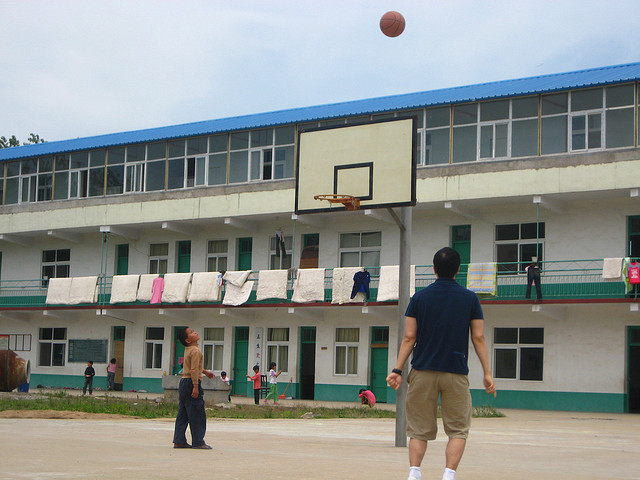<image>What color is the net? There is no net in the image. However, it can be white or orange. What color is the net? I don't know if there is a net in the image. However, it can be seen white or orange. 